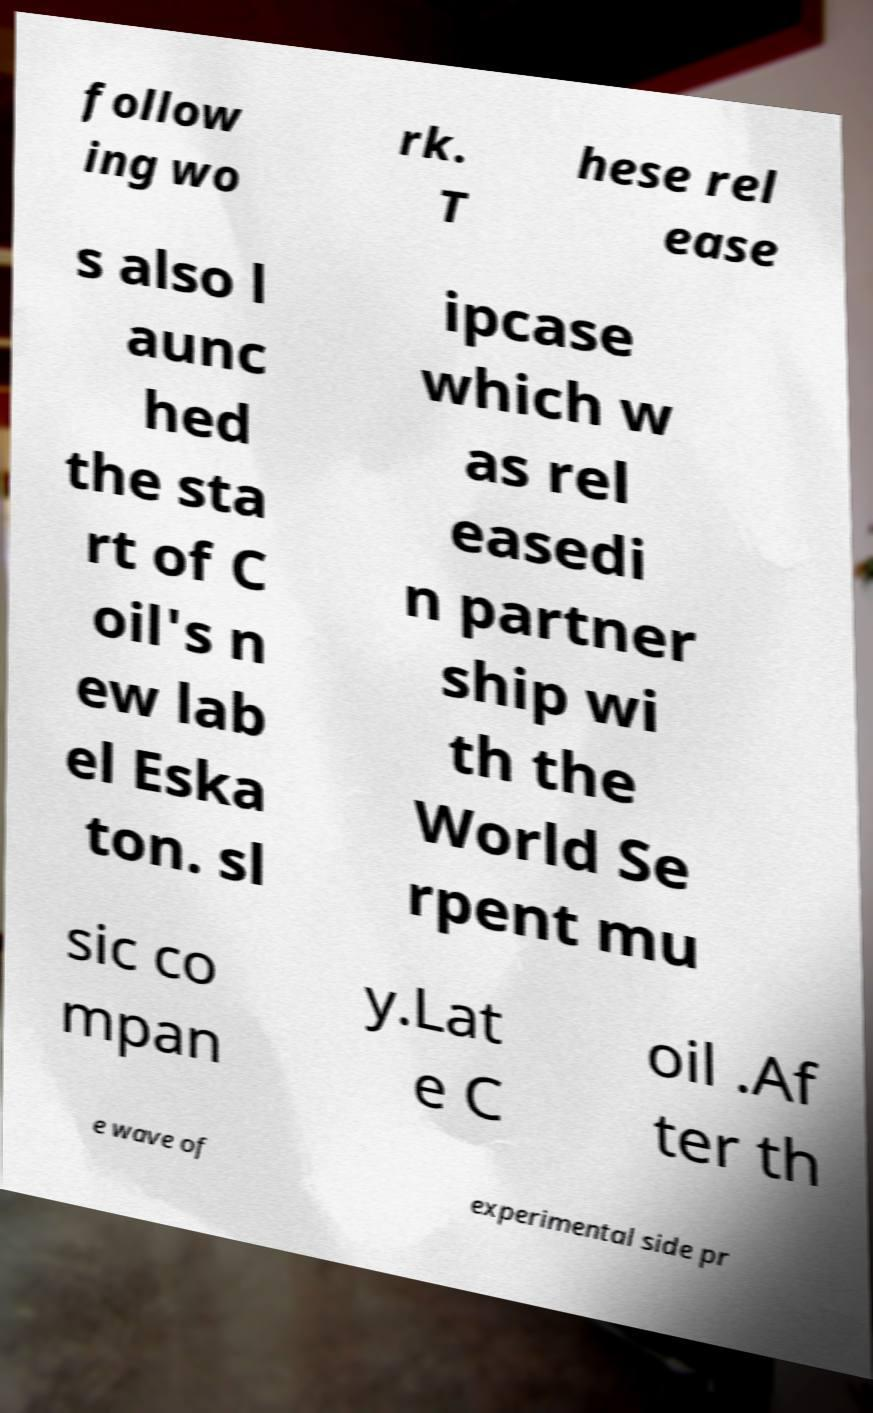Please read and relay the text visible in this image. What does it say? follow ing wo rk. T hese rel ease s also l aunc hed the sta rt of C oil's n ew lab el Eska ton. sl ipcase which w as rel easedi n partner ship wi th the World Se rpent mu sic co mpan y.Lat e C oil .Af ter th e wave of experimental side pr 